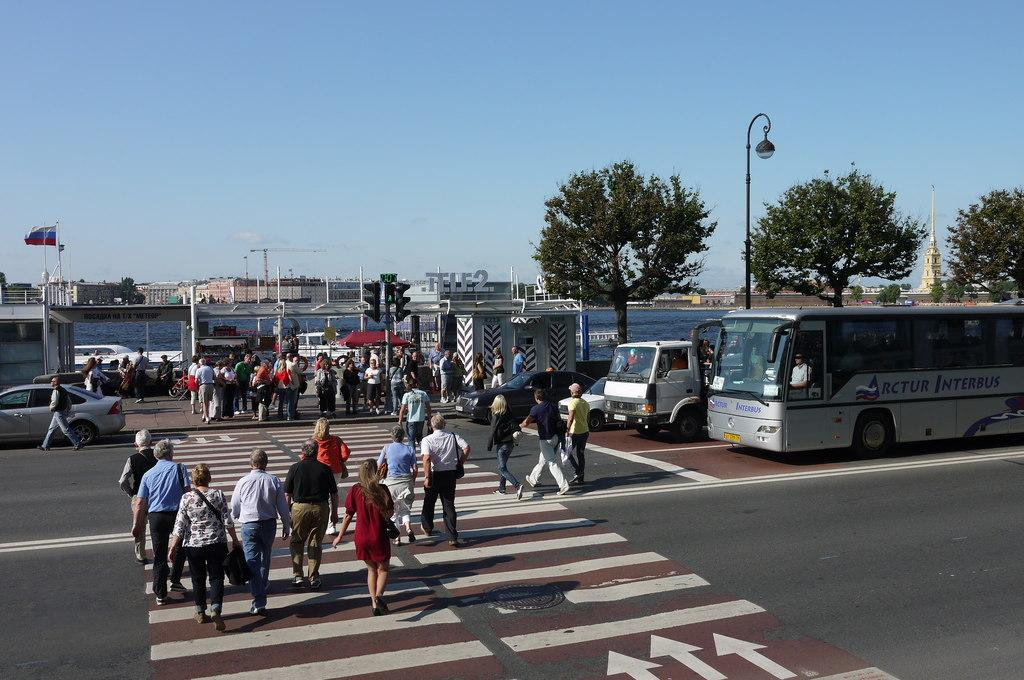What are the people in the image doing? The people in the image are crossing the road. What else can be seen on the right side of the image? There are vehicles on the right side of the image. What type of vegetation is visible in the image? There are trees visible in the image. What is the background of the image? There is an ocean in the backdrop of the image. What type of alley can be seen in the image? There is no alley present in the image. 